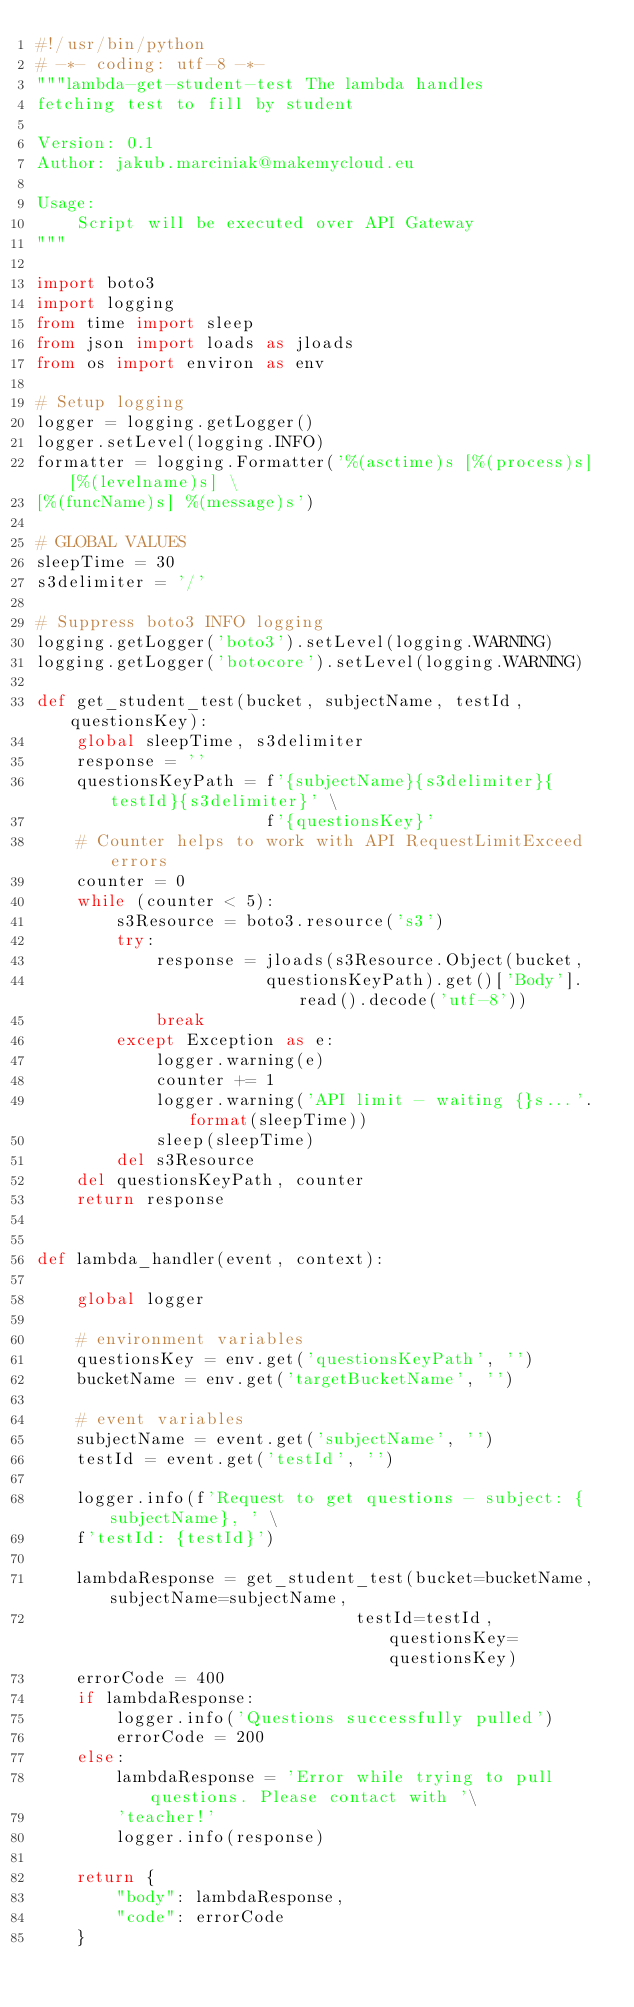Convert code to text. <code><loc_0><loc_0><loc_500><loc_500><_Python_>#!/usr/bin/python
# -*- coding: utf-8 -*-
"""lambda-get-student-test The lambda handles
fetching test to fill by student

Version: 0.1
Author: jakub.marciniak@makemycloud.eu

Usage:
    Script will be executed over API Gateway
"""

import boto3
import logging
from time import sleep
from json import loads as jloads
from os import environ as env

# Setup logging
logger = logging.getLogger()
logger.setLevel(logging.INFO)
formatter = logging.Formatter('%(asctime)s [%(process)s] [%(levelname)s] \
[%(funcName)s] %(message)s')

# GLOBAL VALUES
sleepTime = 30
s3delimiter = '/'

# Suppress boto3 INFO logging
logging.getLogger('boto3').setLevel(logging.WARNING)
logging.getLogger('botocore').setLevel(logging.WARNING)

def get_student_test(bucket, subjectName, testId, questionsKey):
    global sleepTime, s3delimiter
    response = ''
    questionsKeyPath = f'{subjectName}{s3delimiter}{testId}{s3delimiter}' \
                       f'{questionsKey}'
    # Counter helps to work with API RequestLimitExceed errors
    counter = 0
    while (counter < 5):
        s3Resource = boto3.resource('s3')
        try:
            response = jloads(s3Resource.Object(bucket,
                       questionsKeyPath).get()['Body'].read().decode('utf-8'))
            break
        except Exception as e:
            logger.warning(e)
            counter += 1
            logger.warning('API limit - waiting {}s...'.format(sleepTime))
            sleep(sleepTime)
        del s3Resource
    del questionsKeyPath, counter
    return response


def lambda_handler(event, context):

    global logger

    # environment variables
    questionsKey = env.get('questionsKeyPath', '')
    bucketName = env.get('targetBucketName', '')

    # event variables
    subjectName = event.get('subjectName', '')
    testId = event.get('testId', '')

    logger.info(f'Request to get questions - subject: {subjectName}, ' \
    f'testId: {testId}')

    lambdaResponse = get_student_test(bucket=bucketName, subjectName=subjectName,
                                testId=testId, questionsKey=questionsKey)
    errorCode = 400
    if lambdaResponse:
        logger.info('Questions successfully pulled')
        errorCode = 200
    else:
        lambdaResponse = 'Error while trying to pull questions. Please contact with '\
        'teacher!'
        logger.info(response)

    return {
        "body": lambdaResponse,
        "code": errorCode
    }
</code> 